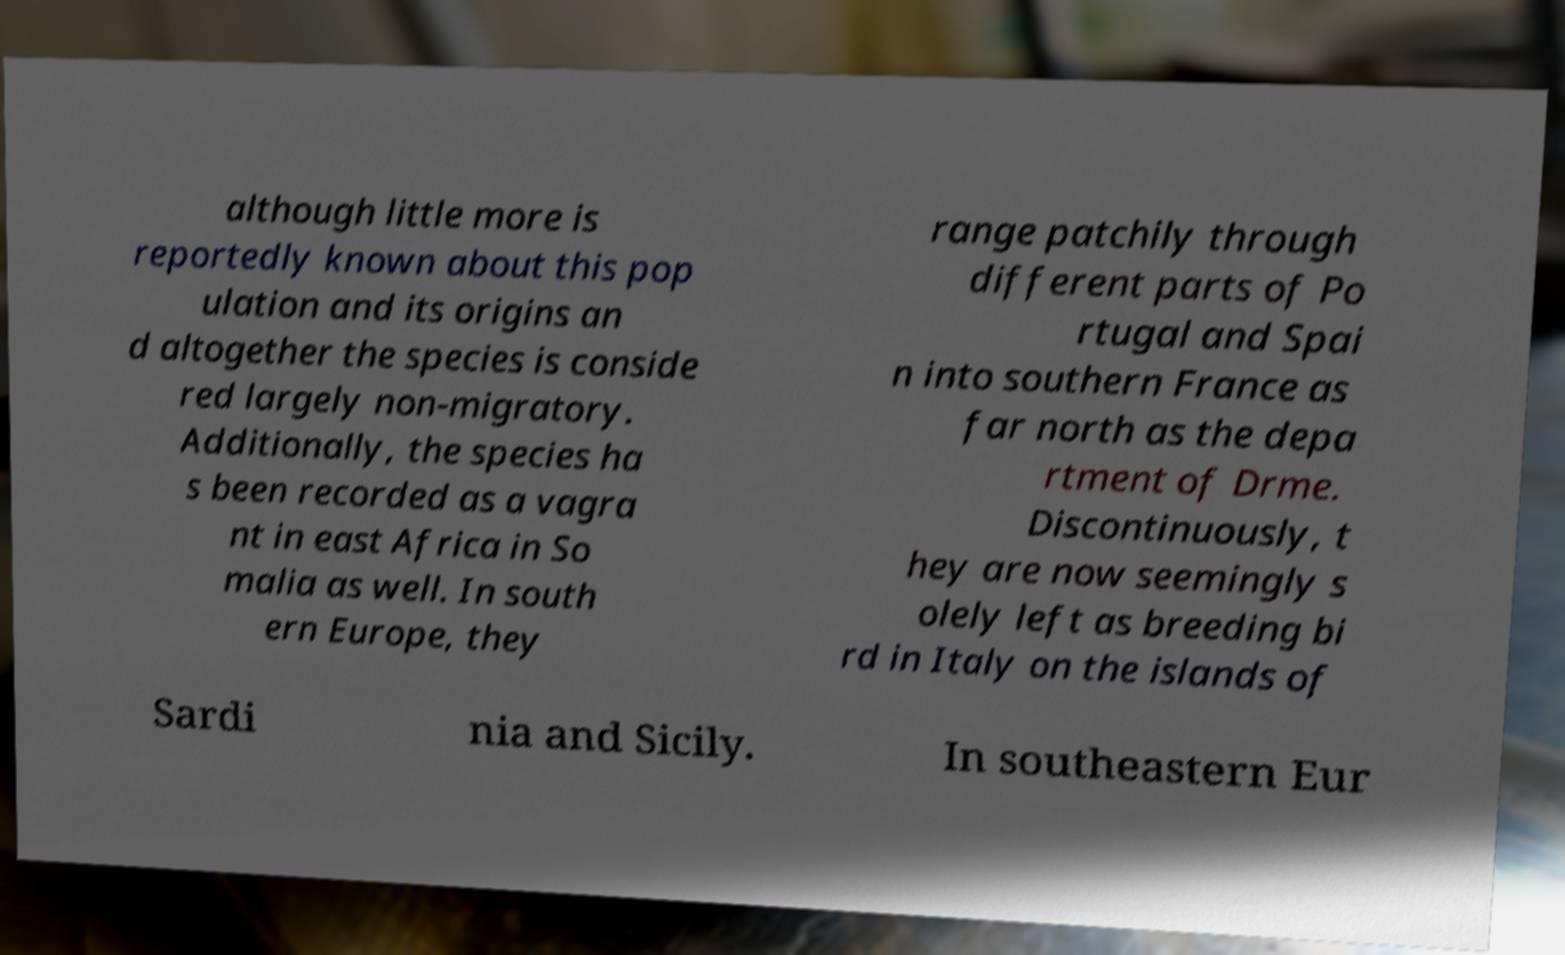Please identify and transcribe the text found in this image. although little more is reportedly known about this pop ulation and its origins an d altogether the species is conside red largely non-migratory. Additionally, the species ha s been recorded as a vagra nt in east Africa in So malia as well. In south ern Europe, they range patchily through different parts of Po rtugal and Spai n into southern France as far north as the depa rtment of Drme. Discontinuously, t hey are now seemingly s olely left as breeding bi rd in Italy on the islands of Sardi nia and Sicily. In southeastern Eur 